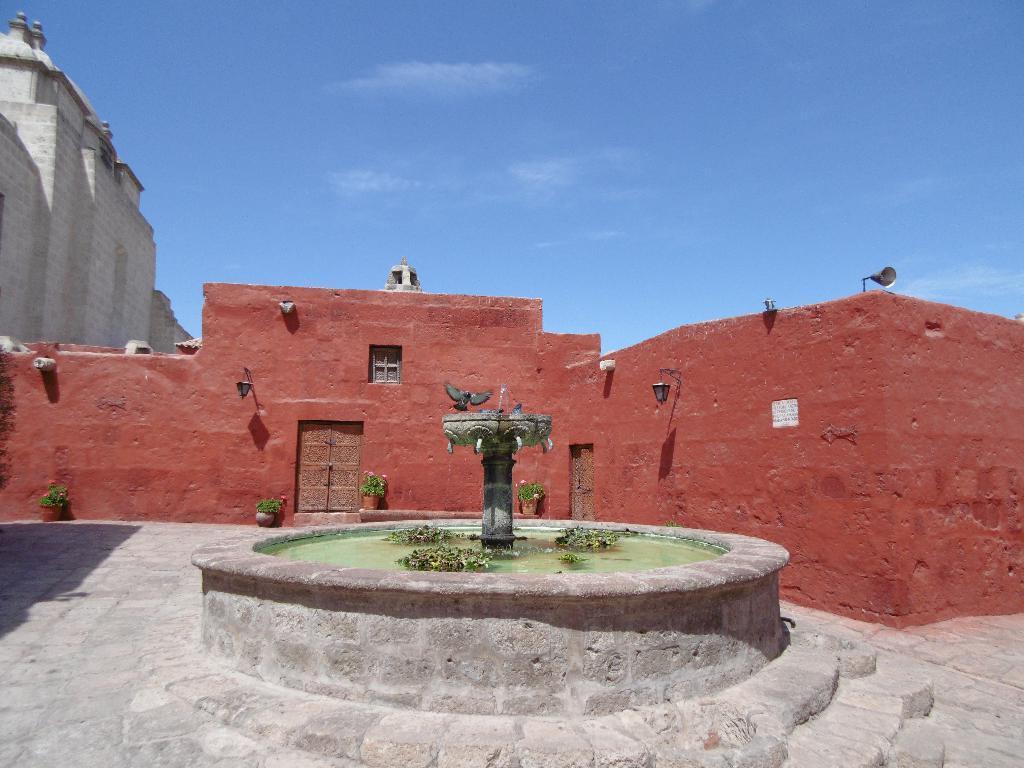Can you describe this image briefly? In this image I can see the fountain and the bird. In the background I can see few buildings in brown and gray color and the sky is in blue and white color. 